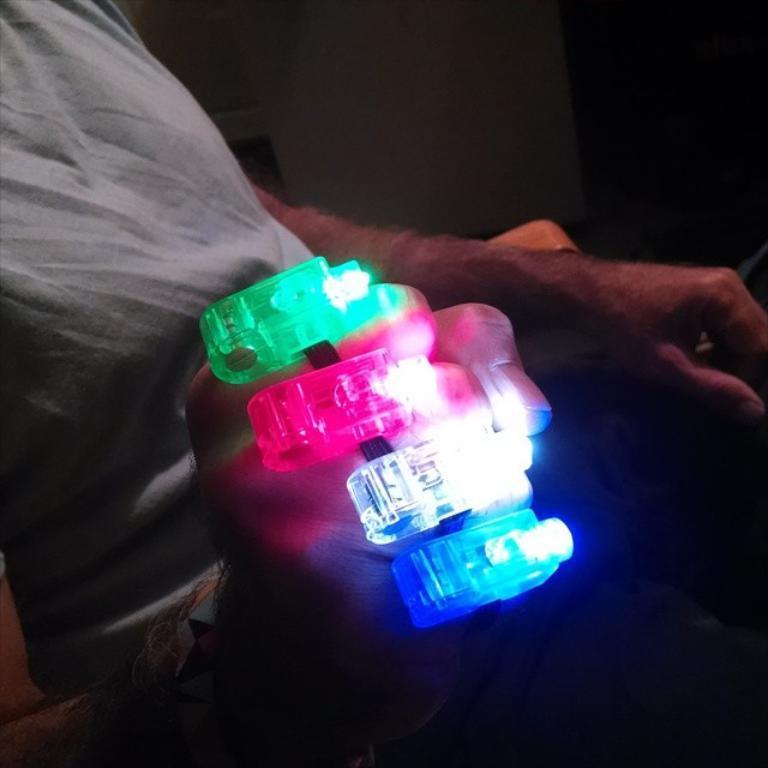Could you give a brief overview of what you see in this image? In this image there is a person sitting on a chair. He is holding an object having lights to it. Background there is a wall. 